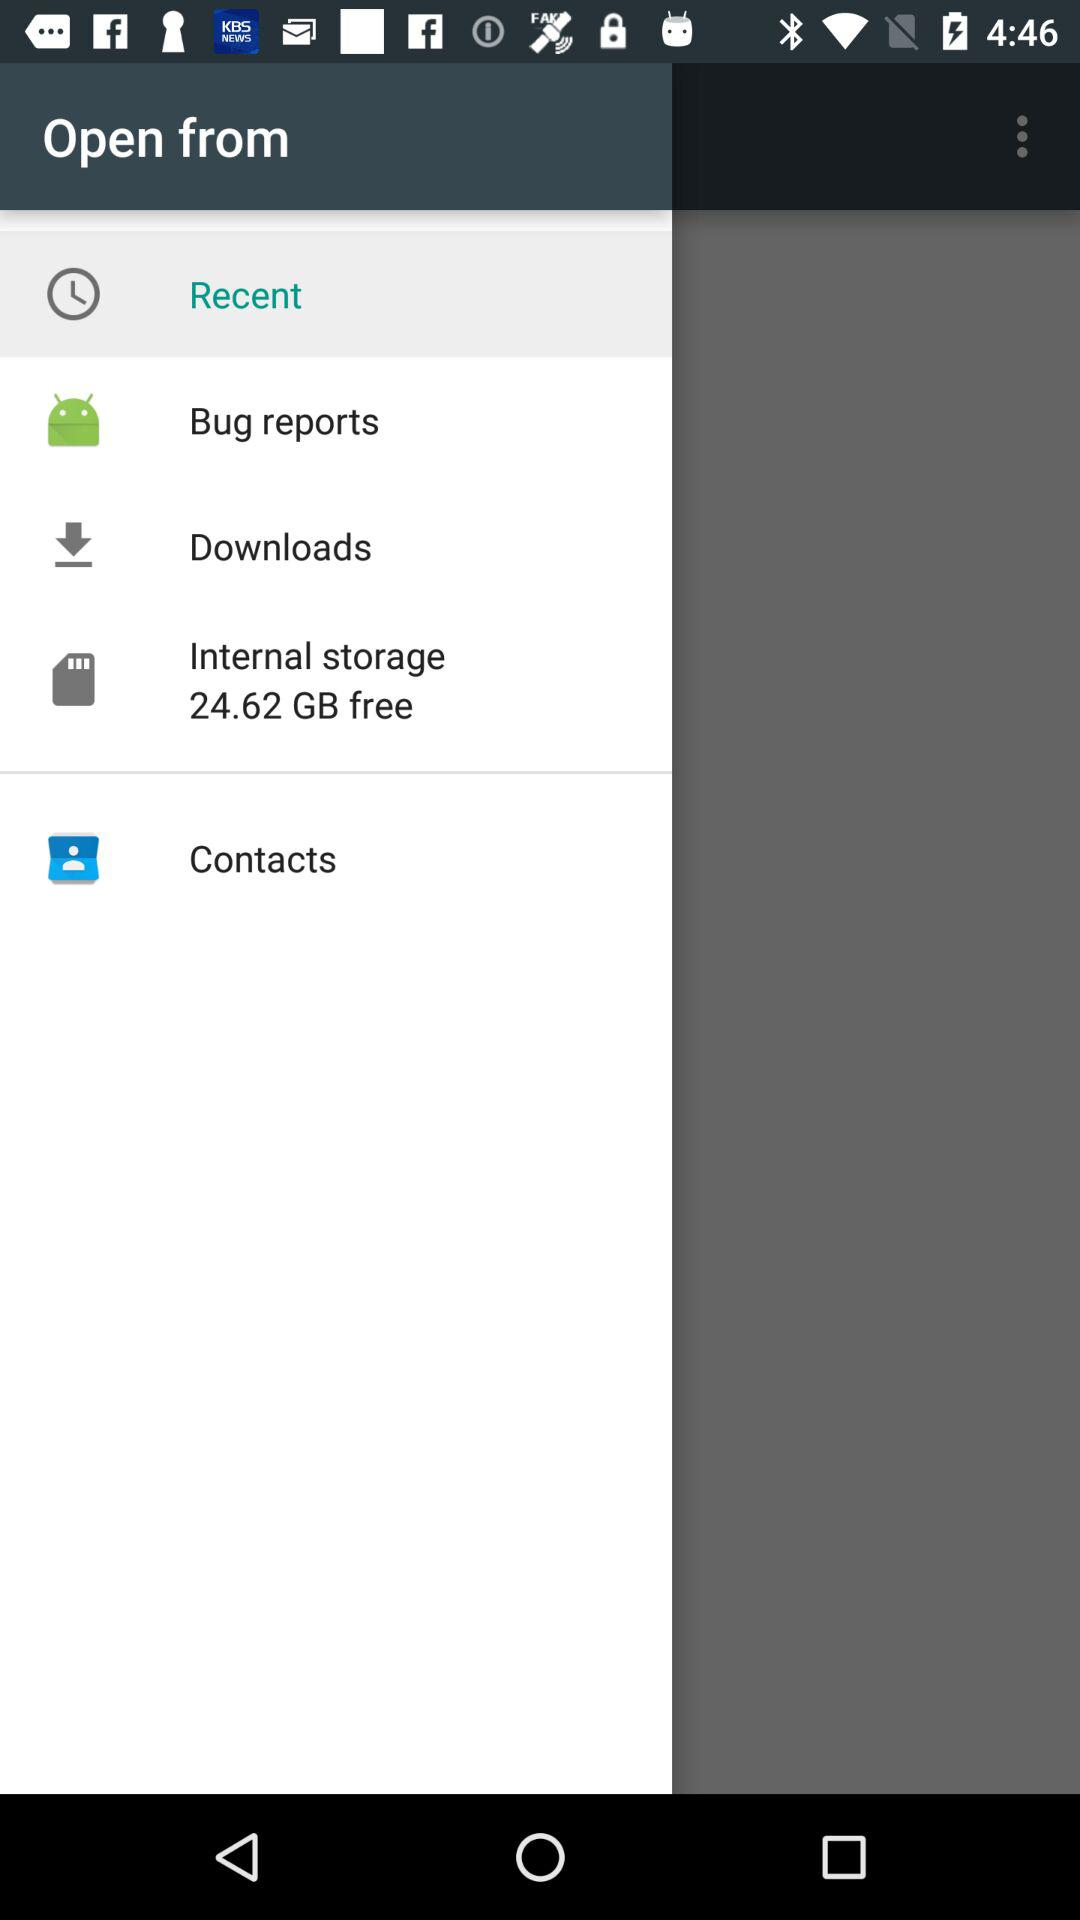How much free space is available on the internal storage?
Answer the question using a single word or phrase. 24.62 GB 